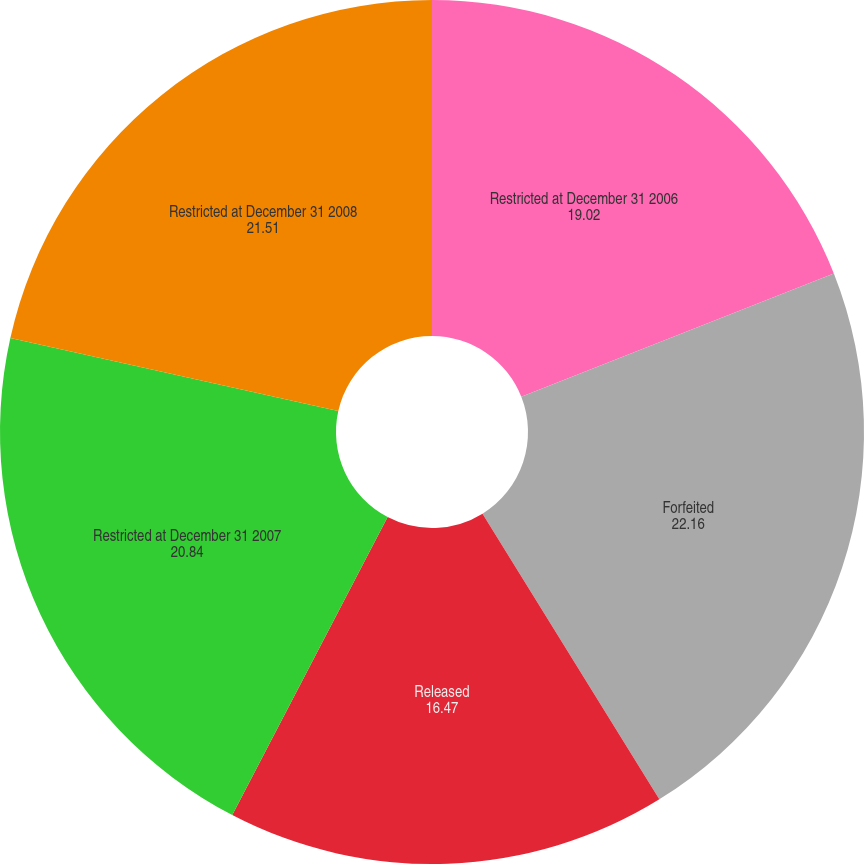<chart> <loc_0><loc_0><loc_500><loc_500><pie_chart><fcel>Restricted at December 31 2006<fcel>Forfeited<fcel>Released<fcel>Restricted at December 31 2007<fcel>Restricted at December 31 2008<nl><fcel>19.02%<fcel>22.16%<fcel>16.47%<fcel>20.84%<fcel>21.51%<nl></chart> 